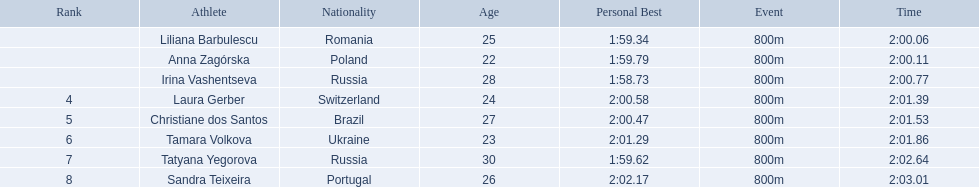Which athletes competed in the 2003 summer universiade - women's 800 metres? Liliana Barbulescu, Anna Zagórska, Irina Vashentseva, Laura Gerber, Christiane dos Santos, Tamara Volkova, Tatyana Yegorova, Sandra Teixeira. Of these, which are from poland? Anna Zagórska. What is her time? 2:00.11. 